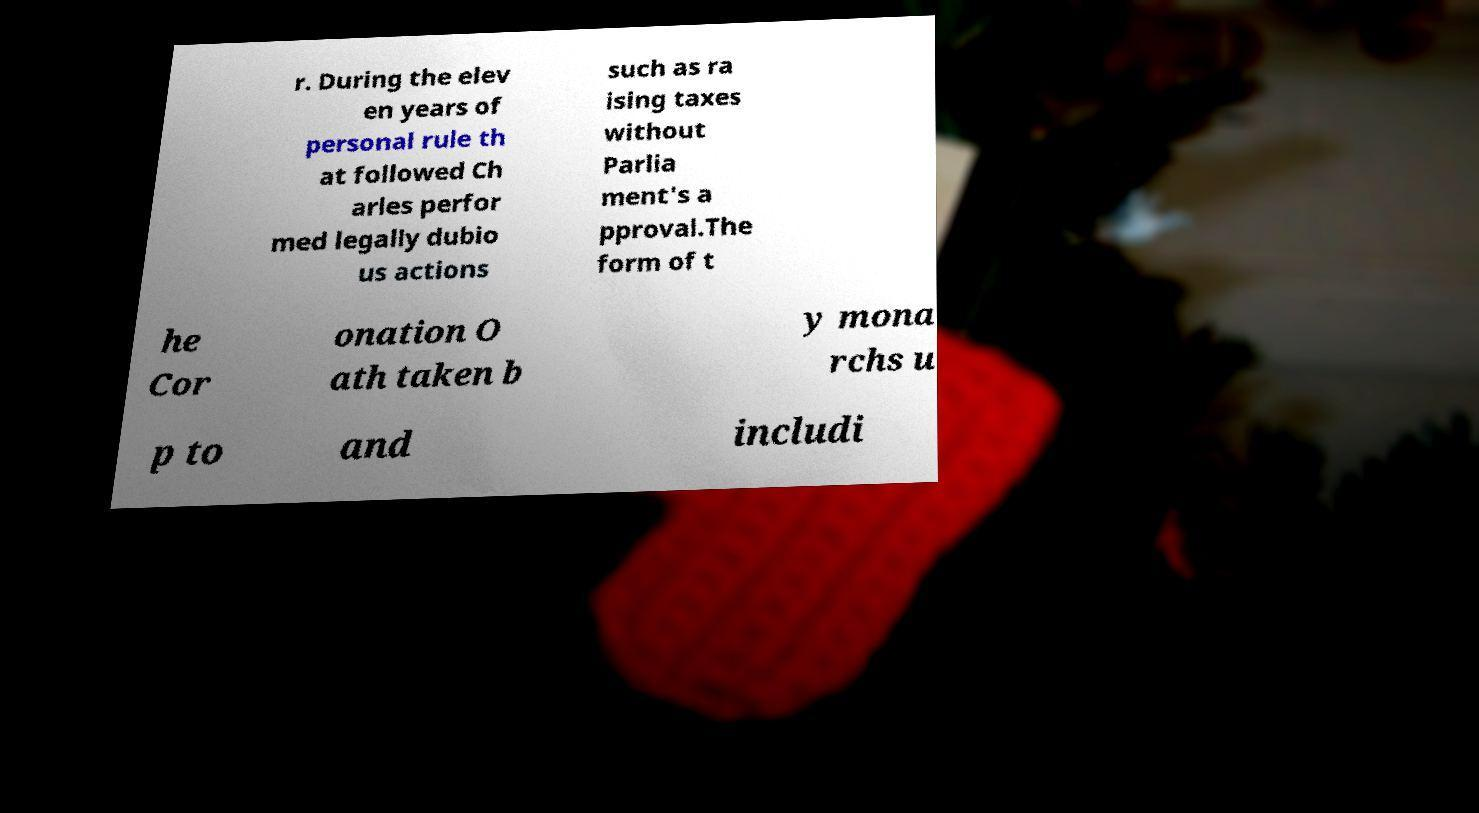Could you assist in decoding the text presented in this image and type it out clearly? r. During the elev en years of personal rule th at followed Ch arles perfor med legally dubio us actions such as ra ising taxes without Parlia ment's a pproval.The form of t he Cor onation O ath taken b y mona rchs u p to and includi 